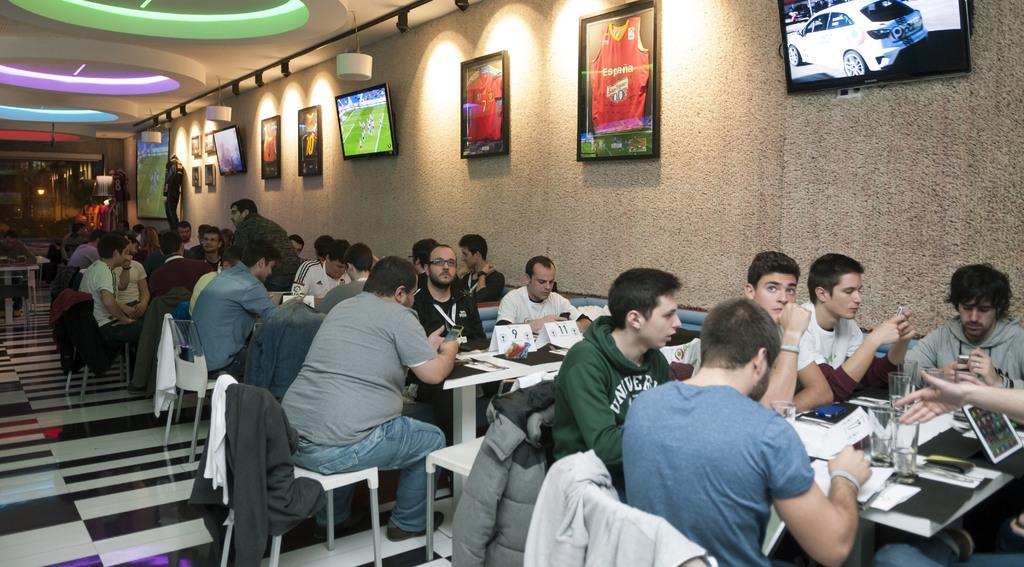What are the people in the image doing? The people in the image are sitting on chairs. What can be seen on the floor in the image? There are tables in the image. What is visible in the background of the image? There is a wall in the background of the image. What is hanging on the wall? There are frames on the wall. What is the structure above the people in the image? The top left side of the image has a roof. What direction are the people facing in the image? The provided facts do not specify the direction the people are facing, so it cannot be determined from the image. 